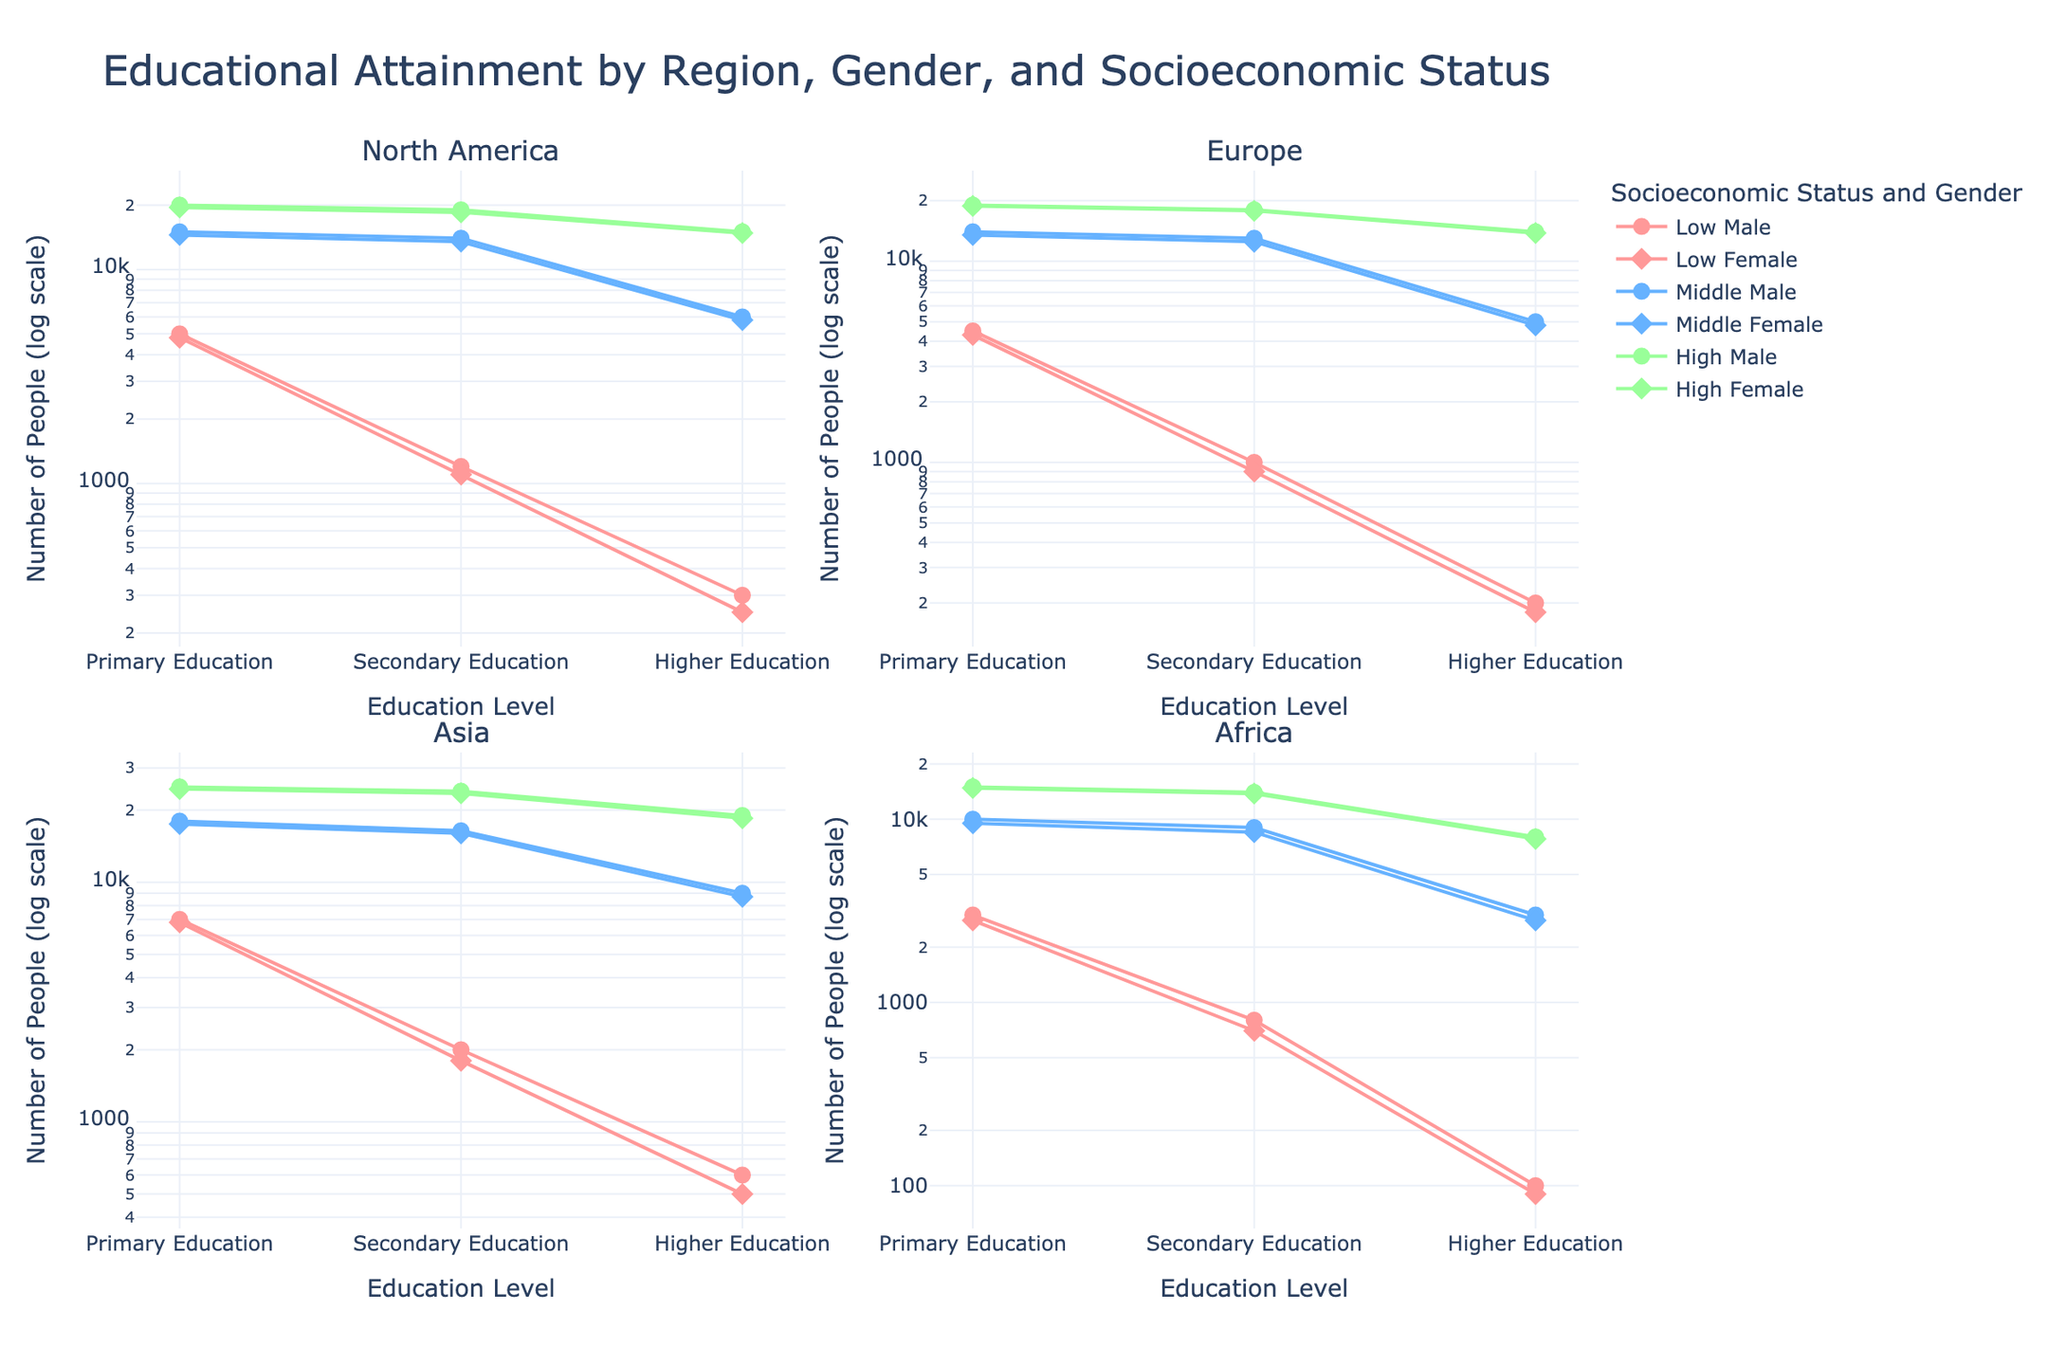What is the title of the figure? The title of the figure is displayed at the top center of the plot. It reads: "Educational Attainment by Region, Gender, and Socioeconomic Status".
Answer: Educational Attainment by Region, Gender, and Socioeconomic Status How many regions are represented in the subplots? There are four subplot titles visible, each representing a different region: "North America", "Europe", "Asia", and "Africa".
Answer: 4 Which gender has a higher number of people with higher education in North America among the Middle socioeconomic status? To determine this, look at the subplot for North America. Compare the markers for 'Middle' socioeconomic status between 'Male' and 'Female' at the 'Higher Education' level. 'Male' has 6000, while 'Female' has 5800.
Answer: Male In Africa, what is the difference in the number of people with secondary education between those with Low and High socioeconomic status for males? Refer to the subplot for Africa. Identify the markers for 'Male' within the 'Low' and 'High' categories at the 'Secondary Education' level. Subtract the 'Low' value (800) from the 'High' value (14000).
Answer: 13200 What trend can be observed in the number of people with secondary education by socioeconomic status for males in Europe? In the subplot for Europe, examine the markers for 'Male' at the 'Secondary Education' level across different socioeconomic statuses. The values are 1000 (Low), 13000 (Middle), and 18000 (High). There is an upward trend as socioeconomic status increases.
Answer: Increasing trend with higher SES Between males and females in Asia, who has more people with primary education in the High socioeconomic status? Look at the subplot for Asia and compare the markers for 'High' socioeconomic status between 'Male' and 'Female' at the 'Primary Education' level. 'Male' has 25000, while 'Female' has 24500.
Answer: Male What is the ratio of males to females with primary education in the Low socioeconomic status in North America? In the subplot for North America, locate the 'Low' socioeconomic status markers for 'Primary Education'. Males have 5000, and females have 4800. The ratio is 5000/4800.
Answer: Approximately 1.04:1 How does the number of people with higher education in Middle socioeconomic status differ between Europe and Asia for females? Compare the 'Higher Education' markers for females in the 'Middle' socioeconomic status in the subplots for Europe (4800) and Asia (8700). Calculate the difference: 8700 - 4800.
Answer: 3900 What pattern can be observed in the plot regarding gender disparities in higher education in Africa across all socioeconomic statuses? Analyze the subplot for Africa at the 'Higher Education' level across all socioeconomic statuses for both genders. 'Male' consistently has higher numbers than 'Female': Low (100 vs 90), Middle (3000 vs 2800), and High (8000 vs 7800). The pattern shows males consistently surpass females.
Answer: Males consistently have higher numbers 